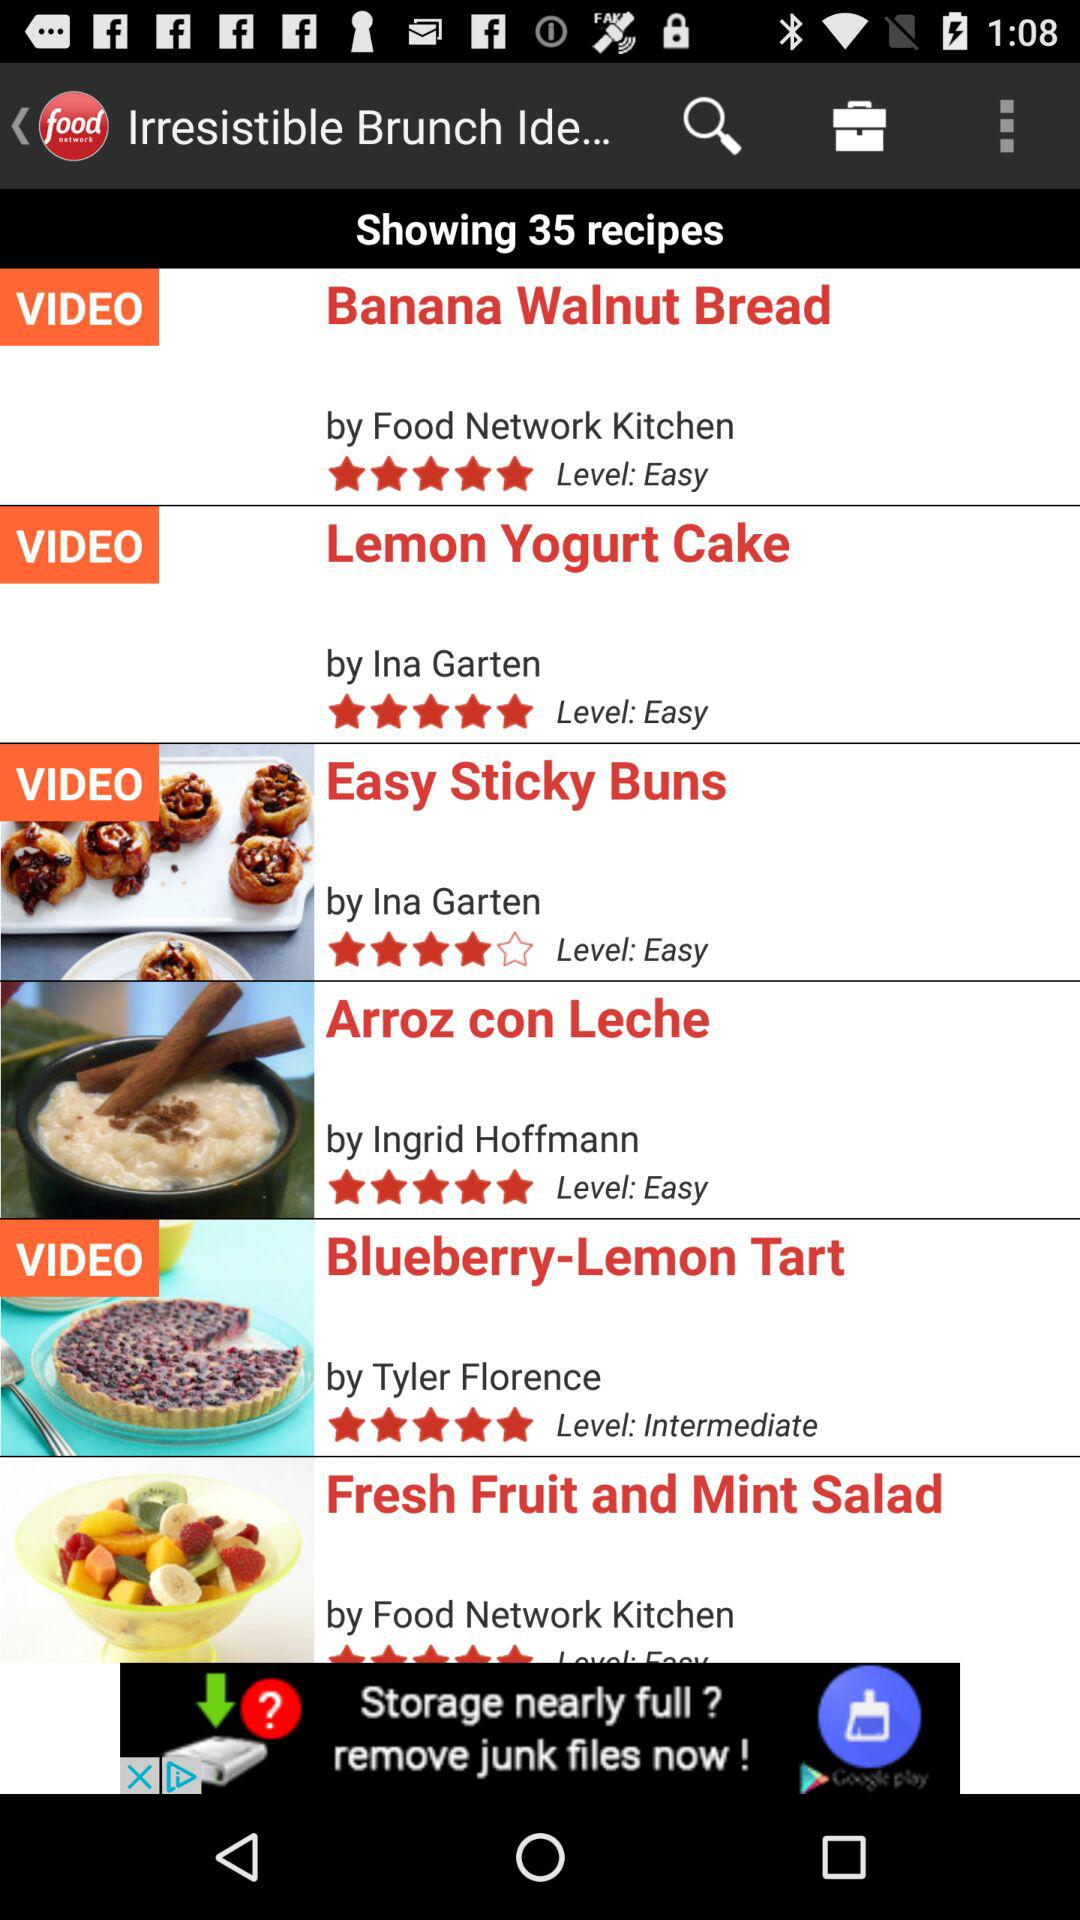What is the level of lemon yoghurt cake? The level is easy. 